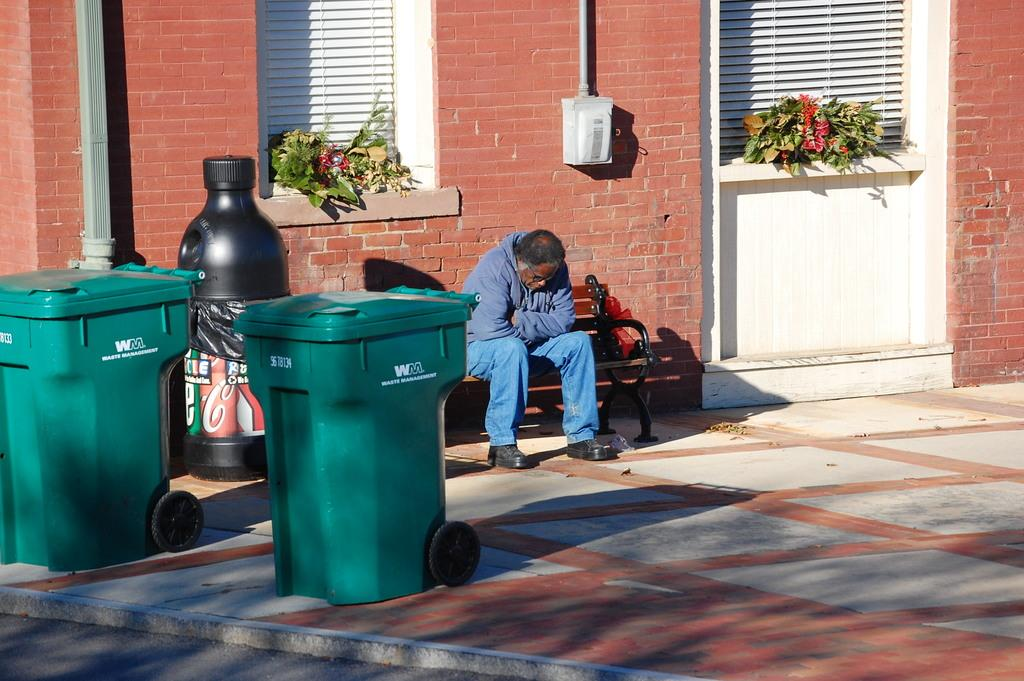<image>
Relay a brief, clear account of the picture shown. A man sits on a bench next to a recycle bin and two Waste Management trashcans. 